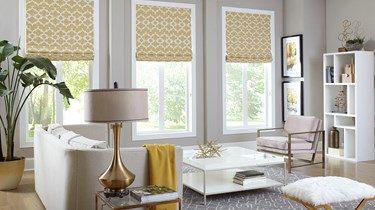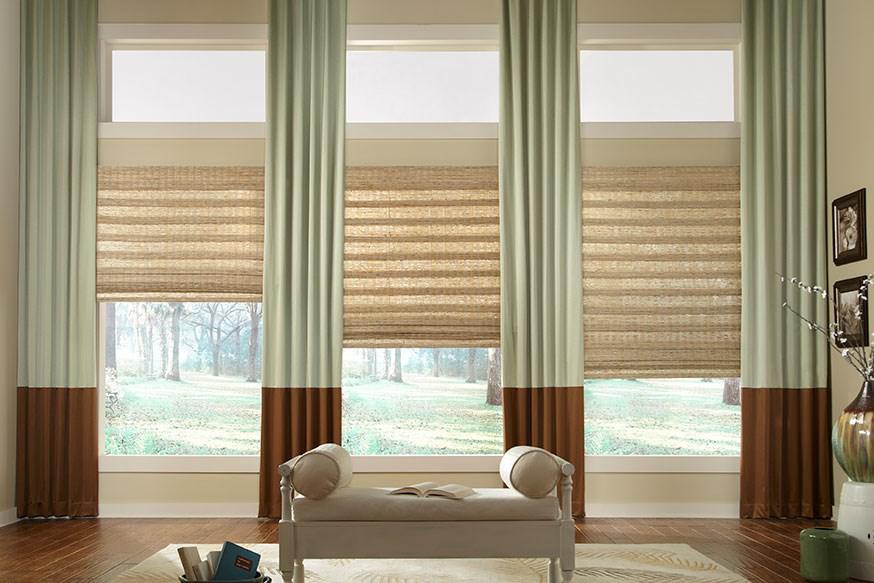The first image is the image on the left, the second image is the image on the right. Examine the images to the left and right. Is the description "There are exactly three shades in the left image." accurate? Answer yes or no. Yes. 